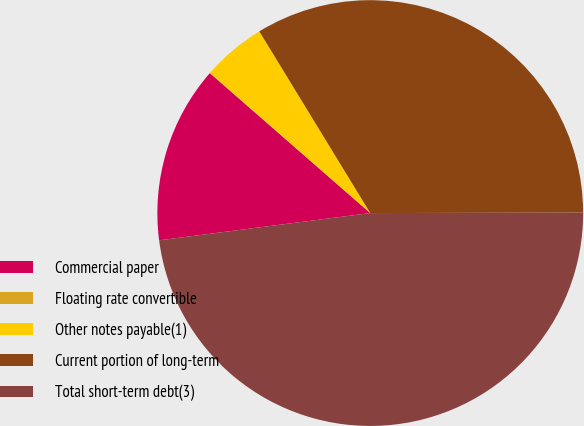Convert chart. <chart><loc_0><loc_0><loc_500><loc_500><pie_chart><fcel>Commercial paper<fcel>Floating rate convertible<fcel>Other notes payable(1)<fcel>Current portion of long-term<fcel>Total short-term debt(3)<nl><fcel>13.46%<fcel>0.03%<fcel>4.83%<fcel>33.69%<fcel>47.99%<nl></chart> 